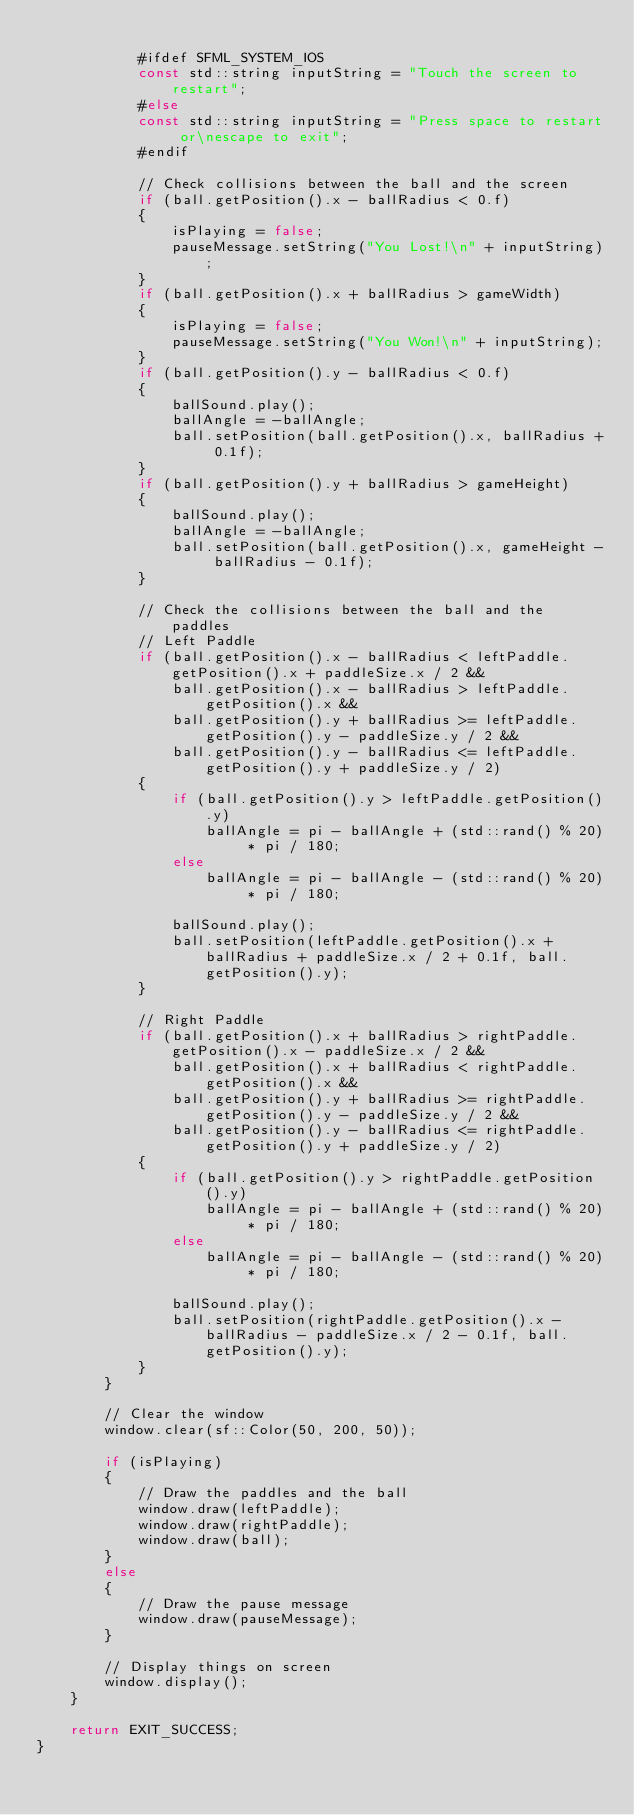Convert code to text. <code><loc_0><loc_0><loc_500><loc_500><_C++_>
            #ifdef SFML_SYSTEM_IOS
            const std::string inputString = "Touch the screen to restart";
            #else
            const std::string inputString = "Press space to restart or\nescape to exit";
            #endif
            
            // Check collisions between the ball and the screen
            if (ball.getPosition().x - ballRadius < 0.f)
            {
                isPlaying = false;
                pauseMessage.setString("You Lost!\n" + inputString);
            }
            if (ball.getPosition().x + ballRadius > gameWidth)
            {
                isPlaying = false;
                pauseMessage.setString("You Won!\n" + inputString);
            }
            if (ball.getPosition().y - ballRadius < 0.f)
            {
                ballSound.play();
                ballAngle = -ballAngle;
                ball.setPosition(ball.getPosition().x, ballRadius + 0.1f);
            }
            if (ball.getPosition().y + ballRadius > gameHeight)
            {
                ballSound.play();
                ballAngle = -ballAngle;
                ball.setPosition(ball.getPosition().x, gameHeight - ballRadius - 0.1f);
            }

            // Check the collisions between the ball and the paddles
            // Left Paddle
            if (ball.getPosition().x - ballRadius < leftPaddle.getPosition().x + paddleSize.x / 2 &&
                ball.getPosition().x - ballRadius > leftPaddle.getPosition().x &&
                ball.getPosition().y + ballRadius >= leftPaddle.getPosition().y - paddleSize.y / 2 &&
                ball.getPosition().y - ballRadius <= leftPaddle.getPosition().y + paddleSize.y / 2)
            {
                if (ball.getPosition().y > leftPaddle.getPosition().y)
                    ballAngle = pi - ballAngle + (std::rand() % 20) * pi / 180;
                else
                    ballAngle = pi - ballAngle - (std::rand() % 20) * pi / 180;

                ballSound.play();
                ball.setPosition(leftPaddle.getPosition().x + ballRadius + paddleSize.x / 2 + 0.1f, ball.getPosition().y);
            }

            // Right Paddle
            if (ball.getPosition().x + ballRadius > rightPaddle.getPosition().x - paddleSize.x / 2 &&
                ball.getPosition().x + ballRadius < rightPaddle.getPosition().x &&
                ball.getPosition().y + ballRadius >= rightPaddle.getPosition().y - paddleSize.y / 2 &&
                ball.getPosition().y - ballRadius <= rightPaddle.getPosition().y + paddleSize.y / 2)
            {
                if (ball.getPosition().y > rightPaddle.getPosition().y)
                    ballAngle = pi - ballAngle + (std::rand() % 20) * pi / 180;
                else
                    ballAngle = pi - ballAngle - (std::rand() % 20) * pi / 180;

                ballSound.play();
                ball.setPosition(rightPaddle.getPosition().x - ballRadius - paddleSize.x / 2 - 0.1f, ball.getPosition().y);
            }
        }

        // Clear the window
        window.clear(sf::Color(50, 200, 50));

        if (isPlaying)
        {
            // Draw the paddles and the ball
            window.draw(leftPaddle);
            window.draw(rightPaddle);
            window.draw(ball);
        }
        else
        {
            // Draw the pause message
            window.draw(pauseMessage);
        }

        // Display things on screen
        window.display();
    }

    return EXIT_SUCCESS;
}
</code> 